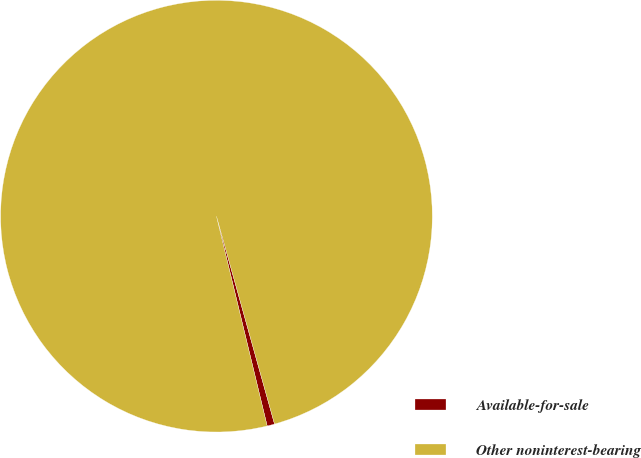Convert chart to OTSL. <chart><loc_0><loc_0><loc_500><loc_500><pie_chart><fcel>Available-for-sale<fcel>Other noninterest-bearing<nl><fcel>0.56%<fcel>99.44%<nl></chart> 